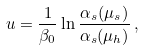Convert formula to latex. <formula><loc_0><loc_0><loc_500><loc_500>u = \frac { 1 } { \beta _ { 0 } } \ln \frac { \alpha _ { s } ( \mu _ { s } ) } { \alpha _ { s } ( \mu _ { h } ) } \, ,</formula> 